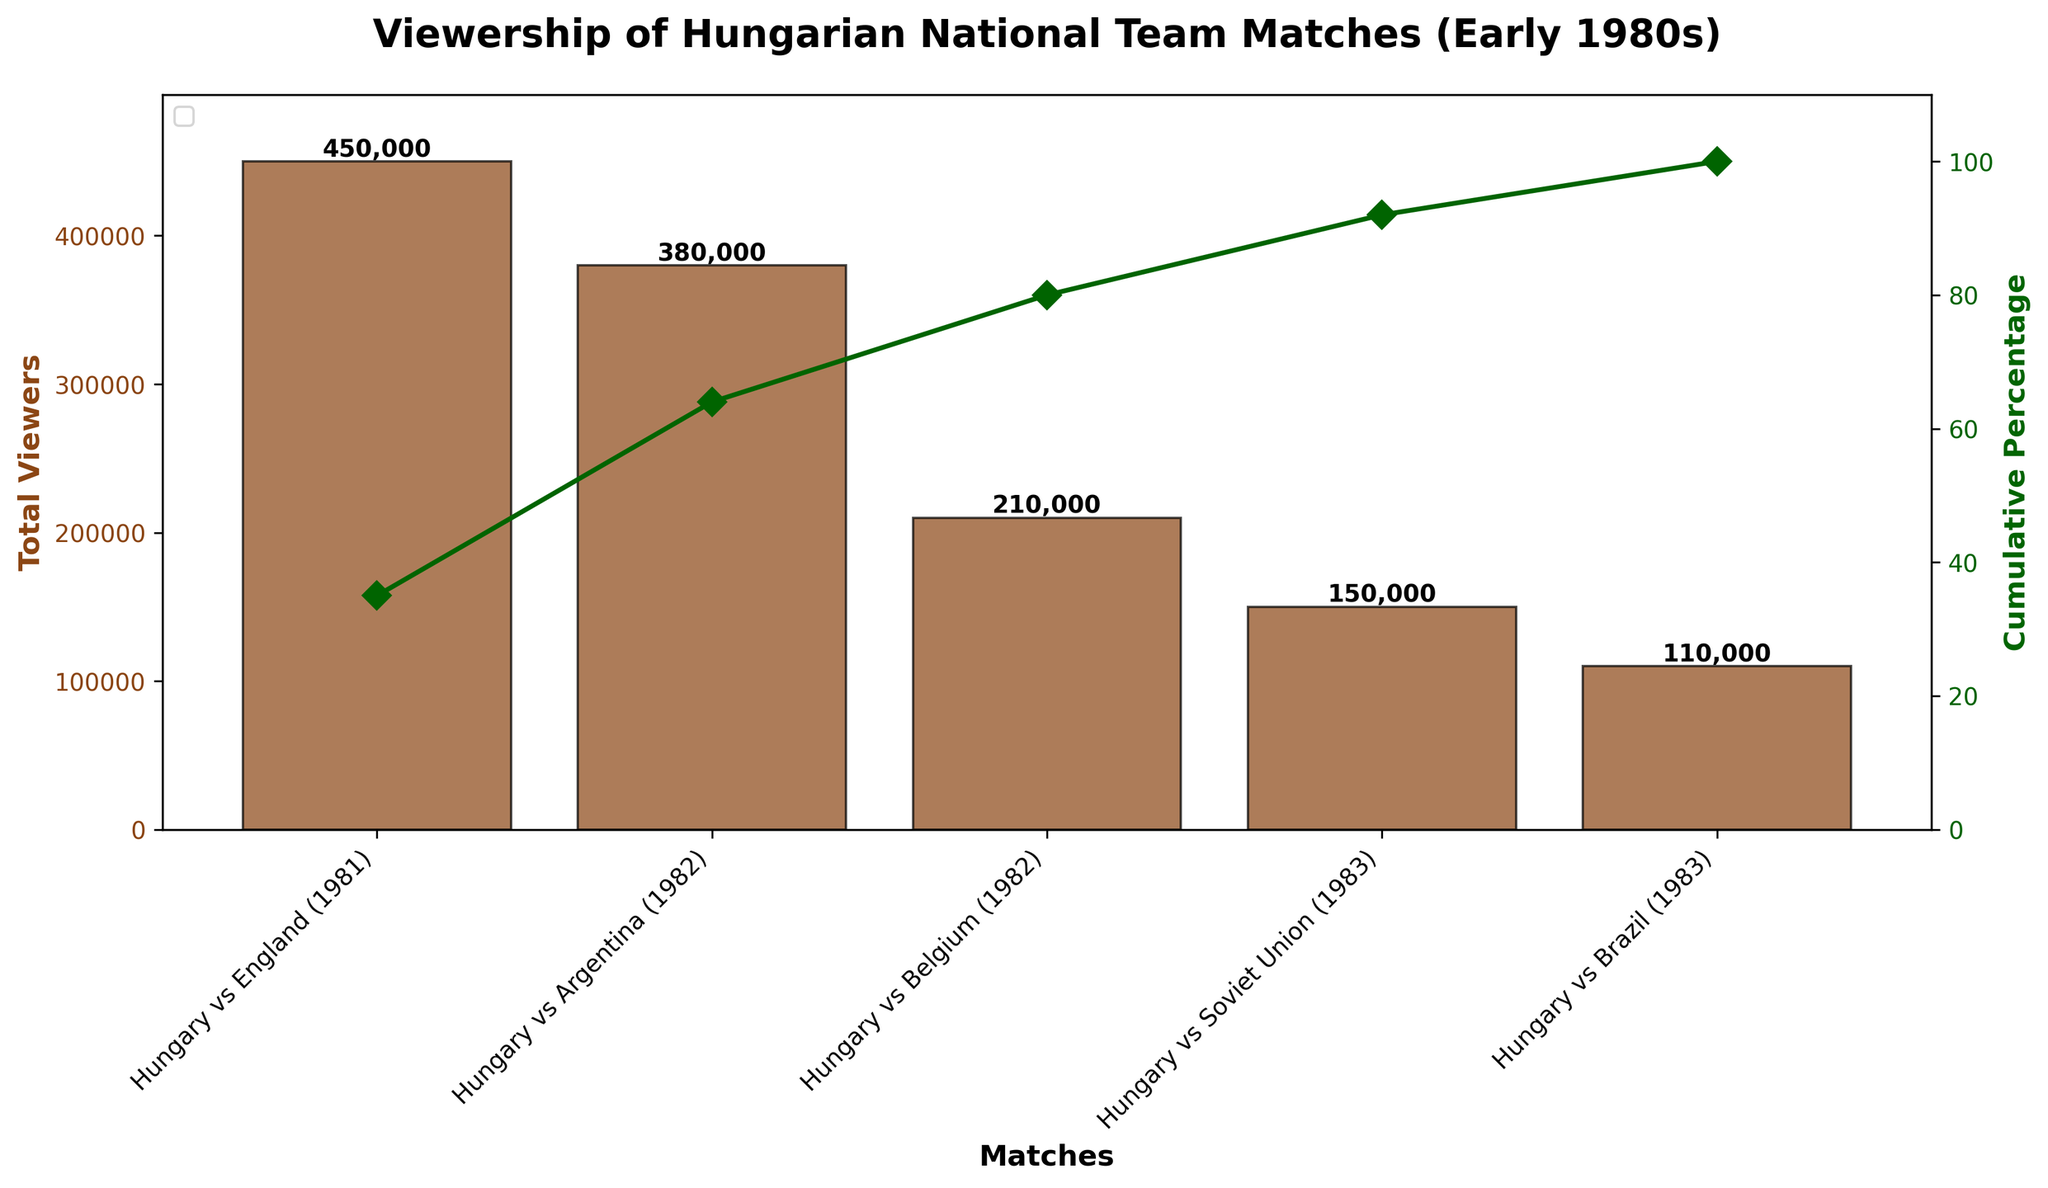What is the title of the figure? The title of the figure is written at the top of the chart. It is meant to describe what the chart shows.
Answer: Viewership of Hungarian National Team Matches (Early 1980s) How many matches are shown in the figure? Count the number of bars representing the matches. Each bar correlates to one match.
Answer: 5 Which match had the highest total viewership? Identify the tallest bar in the chart, which represents the match with the highest viewership.
Answer: Hungary vs England (1981) What is the cumulative percentage after Hungary vs Argentina (1982)? Follow the cumulative percentage line up to the point where it corresponds to Hungary vs Argentina (1982).
Answer: 64% Which match accumulated 80% of the total viewership? Identify the point on the cumulative percentage line that hits 80%, then trace it down to the corresponding match.
Answer: Hungary vs Belgium (1982) Which match had fewer total viewers: Hungary vs Soviet Union (1983) or Hungary vs Brazil (1983)? Compare the heights of the bars for Hungary vs Soviet Union and Hungary vs Brazil.
Answer: Hungary vs Brazil (1983) What is the total viewership sum for Hungary vs Argentina (1982) and Hungary vs Belgium (1982)? Add the total viewers of the matches Hungary vs Argentina (1982) and Hungary vs Belgium (1982), which are provided on their respective bars.
Answer: 590,000 What match has the smallest contribution to the cumulative percentage, and what is that contribution? Identify the match with the shortest bar and check its contribution to the cumulative percentage.
Answer: Hungary vs Brazil (1983), 8% How many matches are required to reach at least 90% cumulative viewership? Follow the cumulative percentage line until it surpasses 90%, and count the matches needed.
Answer: 4 matches 